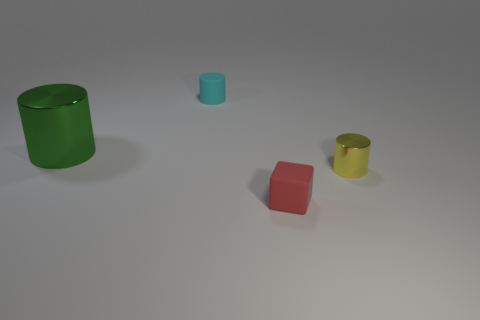Add 1 green metal things. How many objects exist? 5 Subtract all metallic cylinders. How many cylinders are left? 1 Subtract all cubes. How many objects are left? 3 Subtract all brown cylinders. Subtract all yellow cubes. How many cylinders are left? 3 Subtract all cyan cylinders. Subtract all red objects. How many objects are left? 2 Add 1 small red rubber blocks. How many small red rubber blocks are left? 2 Add 1 matte cylinders. How many matte cylinders exist? 2 Subtract 1 yellow cylinders. How many objects are left? 3 